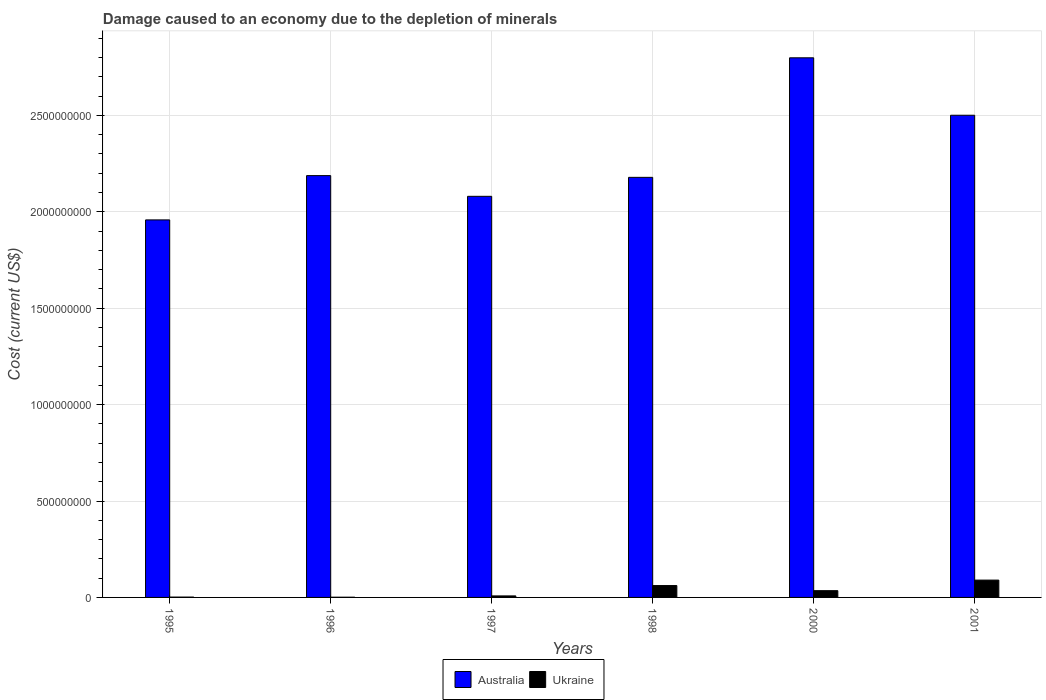How many bars are there on the 3rd tick from the right?
Your answer should be very brief. 2. What is the label of the 4th group of bars from the left?
Your answer should be compact. 1998. In how many cases, is the number of bars for a given year not equal to the number of legend labels?
Make the answer very short. 0. What is the cost of damage caused due to the depletion of minerals in Australia in 2000?
Provide a succinct answer. 2.80e+09. Across all years, what is the maximum cost of damage caused due to the depletion of minerals in Ukraine?
Give a very brief answer. 8.99e+07. Across all years, what is the minimum cost of damage caused due to the depletion of minerals in Ukraine?
Provide a short and direct response. 1.11e+06. What is the total cost of damage caused due to the depletion of minerals in Ukraine in the graph?
Ensure brevity in your answer.  1.97e+08. What is the difference between the cost of damage caused due to the depletion of minerals in Australia in 1997 and that in 2001?
Offer a terse response. -4.20e+08. What is the difference between the cost of damage caused due to the depletion of minerals in Ukraine in 2000 and the cost of damage caused due to the depletion of minerals in Australia in 1996?
Offer a very short reply. -2.15e+09. What is the average cost of damage caused due to the depletion of minerals in Australia per year?
Your response must be concise. 2.28e+09. In the year 1996, what is the difference between the cost of damage caused due to the depletion of minerals in Ukraine and cost of damage caused due to the depletion of minerals in Australia?
Your response must be concise. -2.19e+09. In how many years, is the cost of damage caused due to the depletion of minerals in Ukraine greater than 500000000 US$?
Your answer should be very brief. 0. What is the ratio of the cost of damage caused due to the depletion of minerals in Australia in 1998 to that in 2000?
Offer a terse response. 0.78. What is the difference between the highest and the second highest cost of damage caused due to the depletion of minerals in Ukraine?
Ensure brevity in your answer.  2.83e+07. What is the difference between the highest and the lowest cost of damage caused due to the depletion of minerals in Ukraine?
Ensure brevity in your answer.  8.88e+07. In how many years, is the cost of damage caused due to the depletion of minerals in Ukraine greater than the average cost of damage caused due to the depletion of minerals in Ukraine taken over all years?
Your answer should be very brief. 3. What does the 1st bar from the right in 2000 represents?
Your answer should be compact. Ukraine. How many bars are there?
Provide a succinct answer. 12. How many years are there in the graph?
Offer a terse response. 6. Does the graph contain any zero values?
Offer a very short reply. No. What is the title of the graph?
Make the answer very short. Damage caused to an economy due to the depletion of minerals. What is the label or title of the Y-axis?
Your answer should be compact. Cost (current US$). What is the Cost (current US$) of Australia in 1995?
Provide a short and direct response. 1.96e+09. What is the Cost (current US$) in Ukraine in 1995?
Make the answer very short. 1.74e+06. What is the Cost (current US$) of Australia in 1996?
Make the answer very short. 2.19e+09. What is the Cost (current US$) in Ukraine in 1996?
Make the answer very short. 1.11e+06. What is the Cost (current US$) in Australia in 1997?
Your answer should be compact. 2.08e+09. What is the Cost (current US$) of Ukraine in 1997?
Offer a terse response. 7.90e+06. What is the Cost (current US$) in Australia in 1998?
Your answer should be very brief. 2.18e+09. What is the Cost (current US$) of Ukraine in 1998?
Provide a succinct answer. 6.16e+07. What is the Cost (current US$) of Australia in 2000?
Offer a very short reply. 2.80e+09. What is the Cost (current US$) of Ukraine in 2000?
Your answer should be very brief. 3.50e+07. What is the Cost (current US$) of Australia in 2001?
Make the answer very short. 2.50e+09. What is the Cost (current US$) of Ukraine in 2001?
Provide a succinct answer. 8.99e+07. Across all years, what is the maximum Cost (current US$) of Australia?
Keep it short and to the point. 2.80e+09. Across all years, what is the maximum Cost (current US$) of Ukraine?
Give a very brief answer. 8.99e+07. Across all years, what is the minimum Cost (current US$) of Australia?
Provide a short and direct response. 1.96e+09. Across all years, what is the minimum Cost (current US$) in Ukraine?
Offer a terse response. 1.11e+06. What is the total Cost (current US$) of Australia in the graph?
Keep it short and to the point. 1.37e+1. What is the total Cost (current US$) of Ukraine in the graph?
Make the answer very short. 1.97e+08. What is the difference between the Cost (current US$) in Australia in 1995 and that in 1996?
Your answer should be compact. -2.30e+08. What is the difference between the Cost (current US$) in Ukraine in 1995 and that in 1996?
Ensure brevity in your answer.  6.35e+05. What is the difference between the Cost (current US$) in Australia in 1995 and that in 1997?
Provide a succinct answer. -1.22e+08. What is the difference between the Cost (current US$) of Ukraine in 1995 and that in 1997?
Offer a terse response. -6.15e+06. What is the difference between the Cost (current US$) of Australia in 1995 and that in 1998?
Make the answer very short. -2.21e+08. What is the difference between the Cost (current US$) of Ukraine in 1995 and that in 1998?
Offer a very short reply. -5.98e+07. What is the difference between the Cost (current US$) of Australia in 1995 and that in 2000?
Give a very brief answer. -8.41e+08. What is the difference between the Cost (current US$) of Ukraine in 1995 and that in 2000?
Your response must be concise. -3.33e+07. What is the difference between the Cost (current US$) in Australia in 1995 and that in 2001?
Ensure brevity in your answer.  -5.43e+08. What is the difference between the Cost (current US$) in Ukraine in 1995 and that in 2001?
Your answer should be very brief. -8.81e+07. What is the difference between the Cost (current US$) of Australia in 1996 and that in 1997?
Ensure brevity in your answer.  1.07e+08. What is the difference between the Cost (current US$) of Ukraine in 1996 and that in 1997?
Give a very brief answer. -6.79e+06. What is the difference between the Cost (current US$) of Australia in 1996 and that in 1998?
Your answer should be very brief. 9.03e+06. What is the difference between the Cost (current US$) of Ukraine in 1996 and that in 1998?
Your response must be concise. -6.05e+07. What is the difference between the Cost (current US$) of Australia in 1996 and that in 2000?
Your answer should be compact. -6.11e+08. What is the difference between the Cost (current US$) of Ukraine in 1996 and that in 2000?
Ensure brevity in your answer.  -3.39e+07. What is the difference between the Cost (current US$) of Australia in 1996 and that in 2001?
Provide a short and direct response. -3.13e+08. What is the difference between the Cost (current US$) of Ukraine in 1996 and that in 2001?
Give a very brief answer. -8.88e+07. What is the difference between the Cost (current US$) in Australia in 1997 and that in 1998?
Your answer should be very brief. -9.83e+07. What is the difference between the Cost (current US$) of Ukraine in 1997 and that in 1998?
Provide a short and direct response. -5.37e+07. What is the difference between the Cost (current US$) in Australia in 1997 and that in 2000?
Make the answer very short. -7.18e+08. What is the difference between the Cost (current US$) in Ukraine in 1997 and that in 2000?
Provide a succinct answer. -2.71e+07. What is the difference between the Cost (current US$) in Australia in 1997 and that in 2001?
Give a very brief answer. -4.20e+08. What is the difference between the Cost (current US$) of Ukraine in 1997 and that in 2001?
Give a very brief answer. -8.20e+07. What is the difference between the Cost (current US$) of Australia in 1998 and that in 2000?
Offer a terse response. -6.20e+08. What is the difference between the Cost (current US$) in Ukraine in 1998 and that in 2000?
Offer a very short reply. 2.65e+07. What is the difference between the Cost (current US$) of Australia in 1998 and that in 2001?
Your response must be concise. -3.22e+08. What is the difference between the Cost (current US$) of Ukraine in 1998 and that in 2001?
Provide a short and direct response. -2.83e+07. What is the difference between the Cost (current US$) of Australia in 2000 and that in 2001?
Your answer should be very brief. 2.98e+08. What is the difference between the Cost (current US$) in Ukraine in 2000 and that in 2001?
Offer a terse response. -5.48e+07. What is the difference between the Cost (current US$) of Australia in 1995 and the Cost (current US$) of Ukraine in 1996?
Provide a succinct answer. 1.96e+09. What is the difference between the Cost (current US$) in Australia in 1995 and the Cost (current US$) in Ukraine in 1997?
Provide a short and direct response. 1.95e+09. What is the difference between the Cost (current US$) in Australia in 1995 and the Cost (current US$) in Ukraine in 1998?
Your response must be concise. 1.90e+09. What is the difference between the Cost (current US$) of Australia in 1995 and the Cost (current US$) of Ukraine in 2000?
Offer a terse response. 1.92e+09. What is the difference between the Cost (current US$) of Australia in 1995 and the Cost (current US$) of Ukraine in 2001?
Give a very brief answer. 1.87e+09. What is the difference between the Cost (current US$) of Australia in 1996 and the Cost (current US$) of Ukraine in 1997?
Make the answer very short. 2.18e+09. What is the difference between the Cost (current US$) in Australia in 1996 and the Cost (current US$) in Ukraine in 1998?
Provide a short and direct response. 2.13e+09. What is the difference between the Cost (current US$) of Australia in 1996 and the Cost (current US$) of Ukraine in 2000?
Ensure brevity in your answer.  2.15e+09. What is the difference between the Cost (current US$) of Australia in 1996 and the Cost (current US$) of Ukraine in 2001?
Ensure brevity in your answer.  2.10e+09. What is the difference between the Cost (current US$) of Australia in 1997 and the Cost (current US$) of Ukraine in 1998?
Keep it short and to the point. 2.02e+09. What is the difference between the Cost (current US$) of Australia in 1997 and the Cost (current US$) of Ukraine in 2000?
Offer a very short reply. 2.04e+09. What is the difference between the Cost (current US$) of Australia in 1997 and the Cost (current US$) of Ukraine in 2001?
Provide a short and direct response. 1.99e+09. What is the difference between the Cost (current US$) in Australia in 1998 and the Cost (current US$) in Ukraine in 2000?
Offer a very short reply. 2.14e+09. What is the difference between the Cost (current US$) of Australia in 1998 and the Cost (current US$) of Ukraine in 2001?
Ensure brevity in your answer.  2.09e+09. What is the difference between the Cost (current US$) in Australia in 2000 and the Cost (current US$) in Ukraine in 2001?
Give a very brief answer. 2.71e+09. What is the average Cost (current US$) in Australia per year?
Offer a terse response. 2.28e+09. What is the average Cost (current US$) of Ukraine per year?
Your answer should be very brief. 3.29e+07. In the year 1995, what is the difference between the Cost (current US$) in Australia and Cost (current US$) in Ukraine?
Give a very brief answer. 1.96e+09. In the year 1996, what is the difference between the Cost (current US$) of Australia and Cost (current US$) of Ukraine?
Provide a succinct answer. 2.19e+09. In the year 1997, what is the difference between the Cost (current US$) of Australia and Cost (current US$) of Ukraine?
Provide a short and direct response. 2.07e+09. In the year 1998, what is the difference between the Cost (current US$) in Australia and Cost (current US$) in Ukraine?
Provide a succinct answer. 2.12e+09. In the year 2000, what is the difference between the Cost (current US$) of Australia and Cost (current US$) of Ukraine?
Your answer should be compact. 2.76e+09. In the year 2001, what is the difference between the Cost (current US$) in Australia and Cost (current US$) in Ukraine?
Your answer should be very brief. 2.41e+09. What is the ratio of the Cost (current US$) in Australia in 1995 to that in 1996?
Your response must be concise. 0.9. What is the ratio of the Cost (current US$) of Ukraine in 1995 to that in 1996?
Give a very brief answer. 1.57. What is the ratio of the Cost (current US$) in Ukraine in 1995 to that in 1997?
Ensure brevity in your answer.  0.22. What is the ratio of the Cost (current US$) in Australia in 1995 to that in 1998?
Offer a very short reply. 0.9. What is the ratio of the Cost (current US$) in Ukraine in 1995 to that in 1998?
Your answer should be compact. 0.03. What is the ratio of the Cost (current US$) of Australia in 1995 to that in 2000?
Your answer should be compact. 0.7. What is the ratio of the Cost (current US$) of Ukraine in 1995 to that in 2000?
Your answer should be very brief. 0.05. What is the ratio of the Cost (current US$) of Australia in 1995 to that in 2001?
Ensure brevity in your answer.  0.78. What is the ratio of the Cost (current US$) of Ukraine in 1995 to that in 2001?
Offer a very short reply. 0.02. What is the ratio of the Cost (current US$) in Australia in 1996 to that in 1997?
Ensure brevity in your answer.  1.05. What is the ratio of the Cost (current US$) of Ukraine in 1996 to that in 1997?
Your answer should be compact. 0.14. What is the ratio of the Cost (current US$) in Australia in 1996 to that in 1998?
Make the answer very short. 1. What is the ratio of the Cost (current US$) in Ukraine in 1996 to that in 1998?
Provide a short and direct response. 0.02. What is the ratio of the Cost (current US$) of Australia in 1996 to that in 2000?
Your response must be concise. 0.78. What is the ratio of the Cost (current US$) in Ukraine in 1996 to that in 2000?
Give a very brief answer. 0.03. What is the ratio of the Cost (current US$) of Australia in 1996 to that in 2001?
Ensure brevity in your answer.  0.87. What is the ratio of the Cost (current US$) of Ukraine in 1996 to that in 2001?
Your answer should be compact. 0.01. What is the ratio of the Cost (current US$) of Australia in 1997 to that in 1998?
Make the answer very short. 0.95. What is the ratio of the Cost (current US$) of Ukraine in 1997 to that in 1998?
Your answer should be compact. 0.13. What is the ratio of the Cost (current US$) in Australia in 1997 to that in 2000?
Offer a very short reply. 0.74. What is the ratio of the Cost (current US$) in Ukraine in 1997 to that in 2000?
Make the answer very short. 0.23. What is the ratio of the Cost (current US$) in Australia in 1997 to that in 2001?
Ensure brevity in your answer.  0.83. What is the ratio of the Cost (current US$) of Ukraine in 1997 to that in 2001?
Provide a succinct answer. 0.09. What is the ratio of the Cost (current US$) of Australia in 1998 to that in 2000?
Your response must be concise. 0.78. What is the ratio of the Cost (current US$) in Ukraine in 1998 to that in 2000?
Provide a succinct answer. 1.76. What is the ratio of the Cost (current US$) of Australia in 1998 to that in 2001?
Your answer should be compact. 0.87. What is the ratio of the Cost (current US$) in Ukraine in 1998 to that in 2001?
Keep it short and to the point. 0.69. What is the ratio of the Cost (current US$) of Australia in 2000 to that in 2001?
Your answer should be very brief. 1.12. What is the ratio of the Cost (current US$) of Ukraine in 2000 to that in 2001?
Offer a terse response. 0.39. What is the difference between the highest and the second highest Cost (current US$) in Australia?
Give a very brief answer. 2.98e+08. What is the difference between the highest and the second highest Cost (current US$) in Ukraine?
Ensure brevity in your answer.  2.83e+07. What is the difference between the highest and the lowest Cost (current US$) of Australia?
Your answer should be very brief. 8.41e+08. What is the difference between the highest and the lowest Cost (current US$) of Ukraine?
Give a very brief answer. 8.88e+07. 